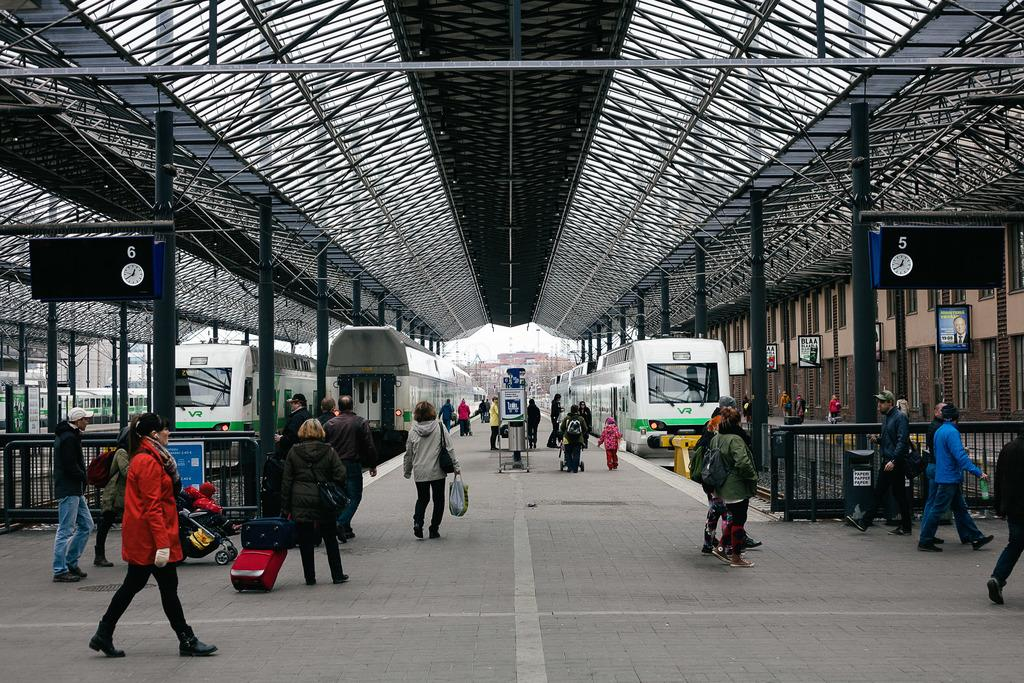What are the people in the image doing? The people in the image are walking on the road. What type of transportation can be seen in the image? There are trains in the image. What structures are present at the top of the image? There are rods visible at the top of the image. What safety feature can be seen in the image? There are railings in the image. How many oranges are being used as currency in the image? There are no oranges present in the image, and therefore no currency exchange can be observed. What type of gun is being used by the people walking on the road in the image? There is no gun present in the image; the people are simply walking on the road. 